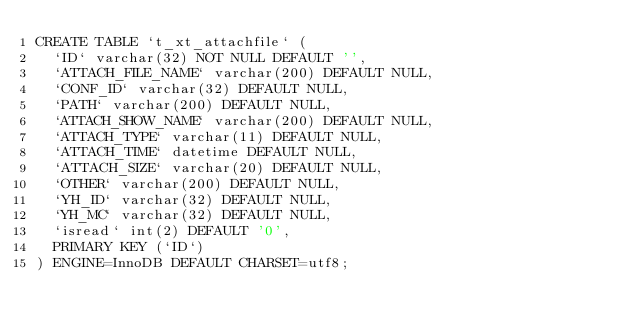Convert code to text. <code><loc_0><loc_0><loc_500><loc_500><_SQL_>CREATE TABLE `t_xt_attachfile` (
  `ID` varchar(32) NOT NULL DEFAULT '',
  `ATTACH_FILE_NAME` varchar(200) DEFAULT NULL,
  `CONF_ID` varchar(32) DEFAULT NULL,
  `PATH` varchar(200) DEFAULT NULL,
  `ATTACH_SHOW_NAME` varchar(200) DEFAULT NULL,
  `ATTACH_TYPE` varchar(11) DEFAULT NULL,
  `ATTACH_TIME` datetime DEFAULT NULL,
  `ATTACH_SIZE` varchar(20) DEFAULT NULL,
  `OTHER` varchar(200) DEFAULT NULL,
  `YH_ID` varchar(32) DEFAULT NULL,
  `YH_MC` varchar(32) DEFAULT NULL,
  `isread` int(2) DEFAULT '0',
  PRIMARY KEY (`ID`)
) ENGINE=InnoDB DEFAULT CHARSET=utf8;</code> 